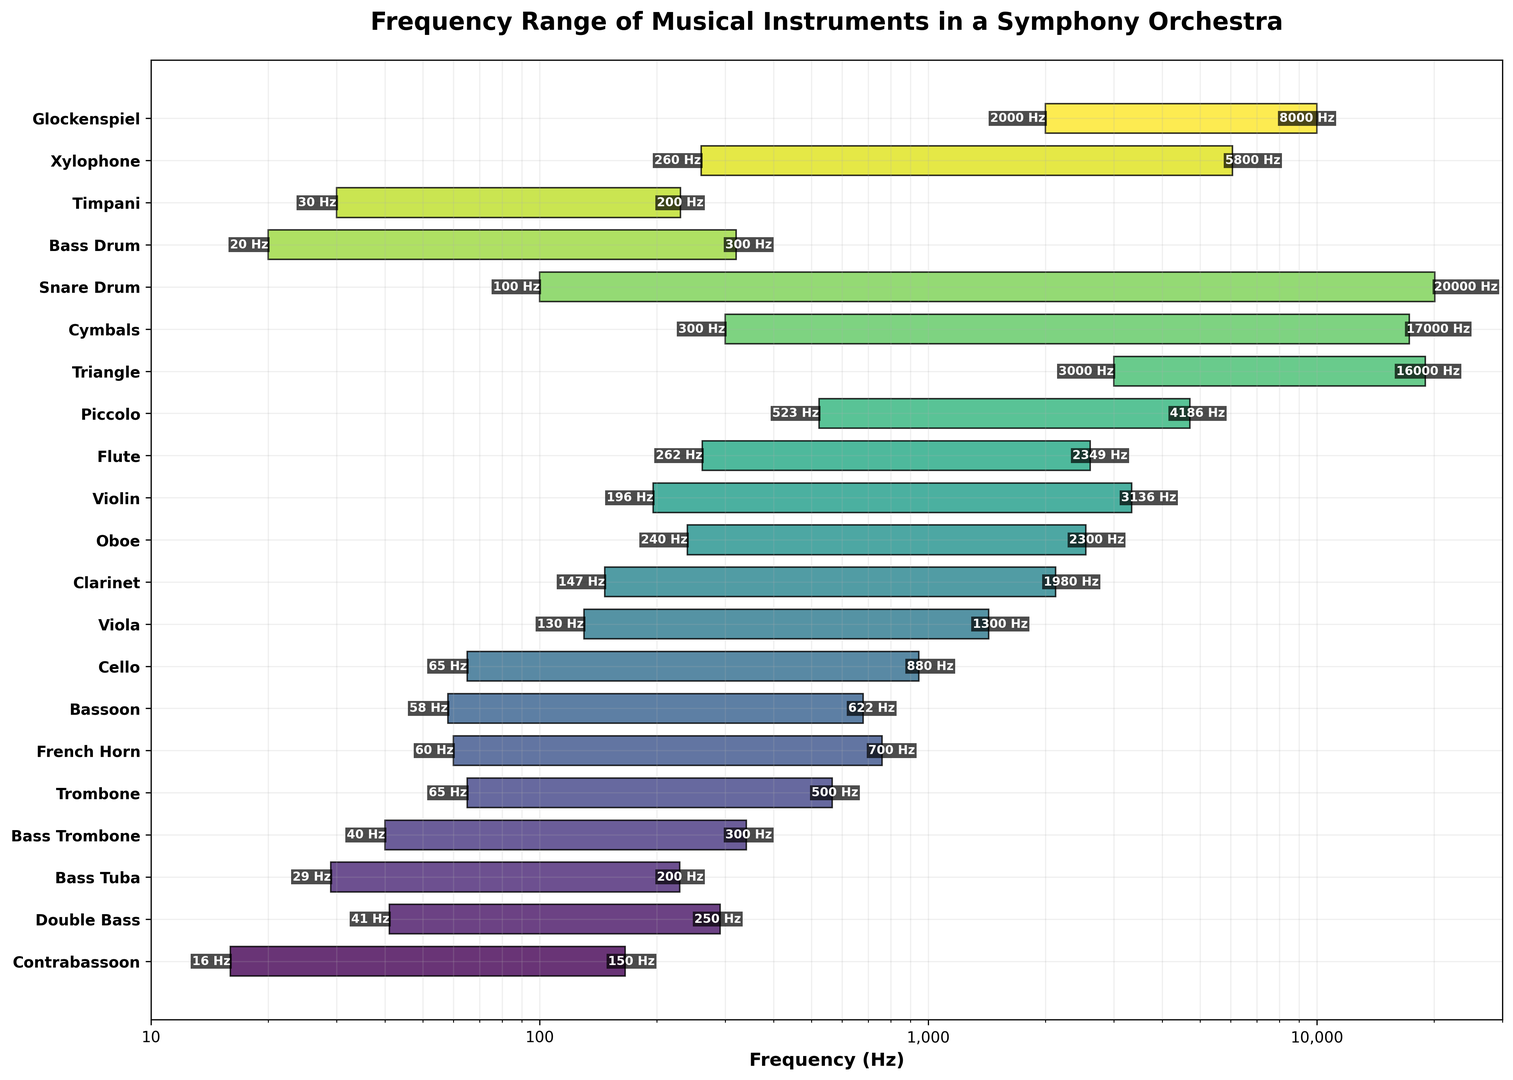Which instrument has the highest upper frequency limit? Look for the instrument whose bar reaches the furthest right on the x-axis. The highest point on the x-axis for any instrument is 20,000 Hz, achieved by the Snare Drum.
Answer: Snare Drum Which instrument has the lowest frequency range overall? Identify the instrument with the lowest starting point on the x-axis. The Contrabassoon starts at 16 Hz, which is the lowest among all instruments.
Answer: Contrabassoon Which instrument has the widest frequency range? Calculate the frequency range (highest minus lowest frequency) for each instrument and find the maximum. Snare Drum ranges from 100 Hz to 20,000 Hz, totaling 19,900 Hz, which is the widest range.
Answer: Snare Drum Compare the highest frequencies of the Violin and Viola. Which one is higher? Look at the highest points reached by the bars of the Violin and Viola. The Violin reaches up to 3,136 Hz, whereas the Viola only reaches 1,300 Hz. Thus, the Violin has the higher upper frequency limit.
Answer: Violin Which instrument in the percussion section reaches the lowest frequency, and what is that frequency? Identify the lowest frequency among the percussion instruments (Triangle, Cymbals, Snare Drum, Bass Drum, Timpani, Xylophone, Glockenspiel). The Bass Drum reaches the lowest frequency of 20 Hz.
Answer: Bass Drum, 20 Hz What is the range of the Flute in Hz? Subtract the lowest frequency from the highest frequency for the Flute. The Flute ranges from 262 Hz to 2,349 Hz, so its range is 2,349 - 262 = 2,087 Hz.
Answer: 2,087 Hz Are there any instruments that have both their low and high frequencies entirely above 1,000 Hz? Check the lowest frequencies of all instruments to see if any start above 1,000 Hz and end above 1,000 Hz. The Glockenspiel and Triangle both fit this criterion.
Answer: Glockenspiel, Triangle Order the string instruments by their highest frequency, starting from the lowest. Look at the highest frequency values for Double Bass, Cello, Viola, and Violin, and order them. Double Bass (250 Hz), Cello (880 Hz), Viola (1,300 Hz), Violin (3,136 Hz).
Answer: Double Bass, Cello, Viola, Violin Which woodwind instrument covers the largest frequency range? Calculate the frequency range for each woodwind instrument (Bassoon, Clarinet, Oboe, Flute, Piccolo). The Clarinet ranges from 147 Hz to 1,980 Hz, giving a range of 1,833 Hz, which is the largest.
Answer: Clarinet Is the highest frequency of the French Horn higher or lower than the lowest frequency of the Violin? Compare the highest frequency of the French Horn at 700 Hz and the lowest frequency of the Violin at 196 Hz. The highest frequency of the French Horn is higher.
Answer: Higher 